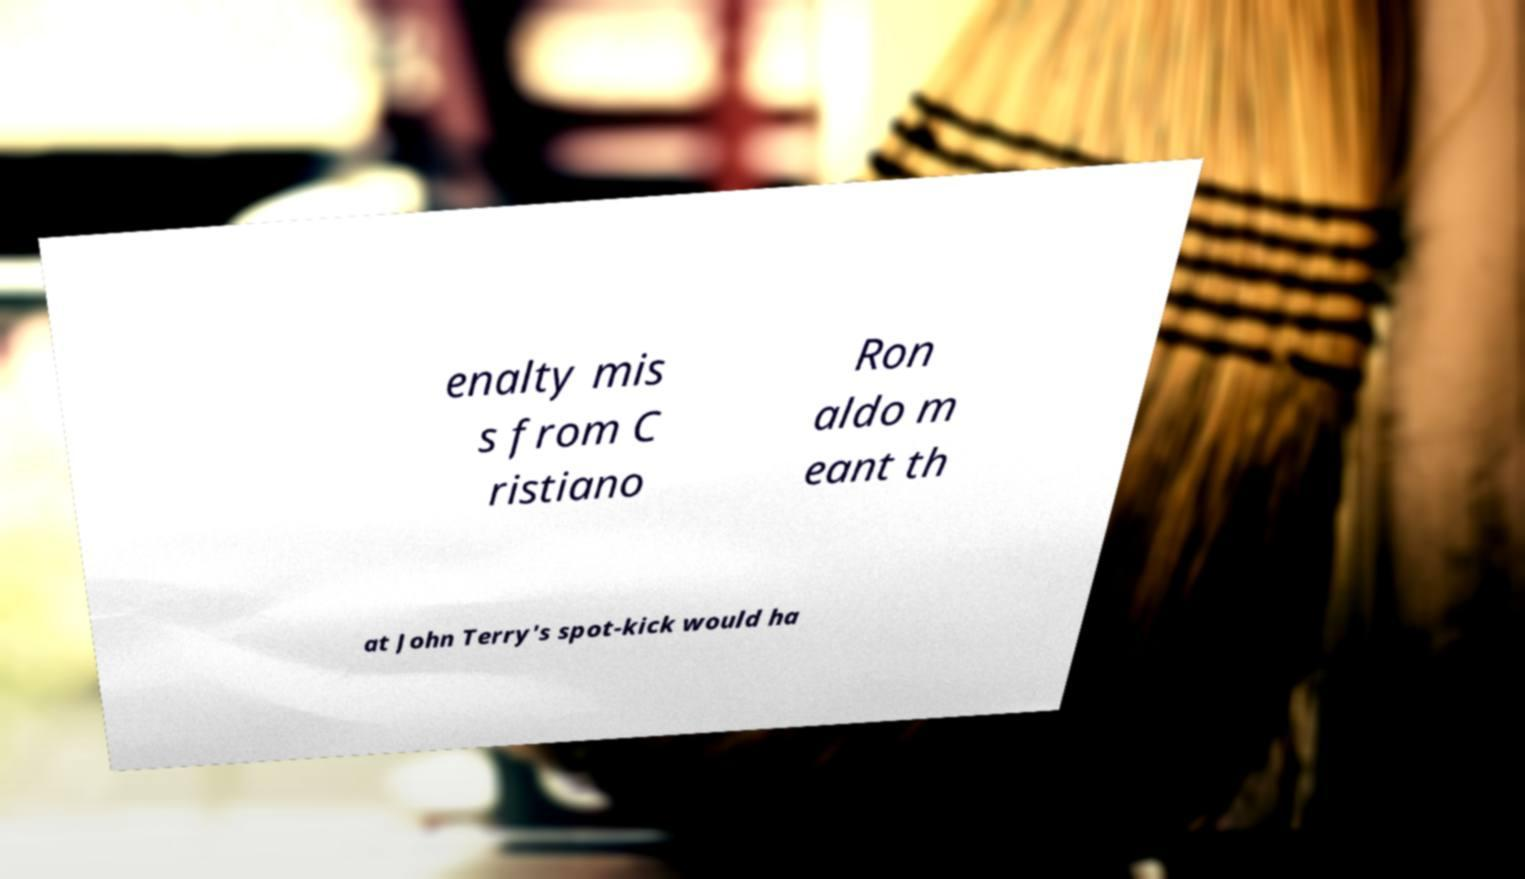Can you accurately transcribe the text from the provided image for me? enalty mis s from C ristiano Ron aldo m eant th at John Terry's spot-kick would ha 